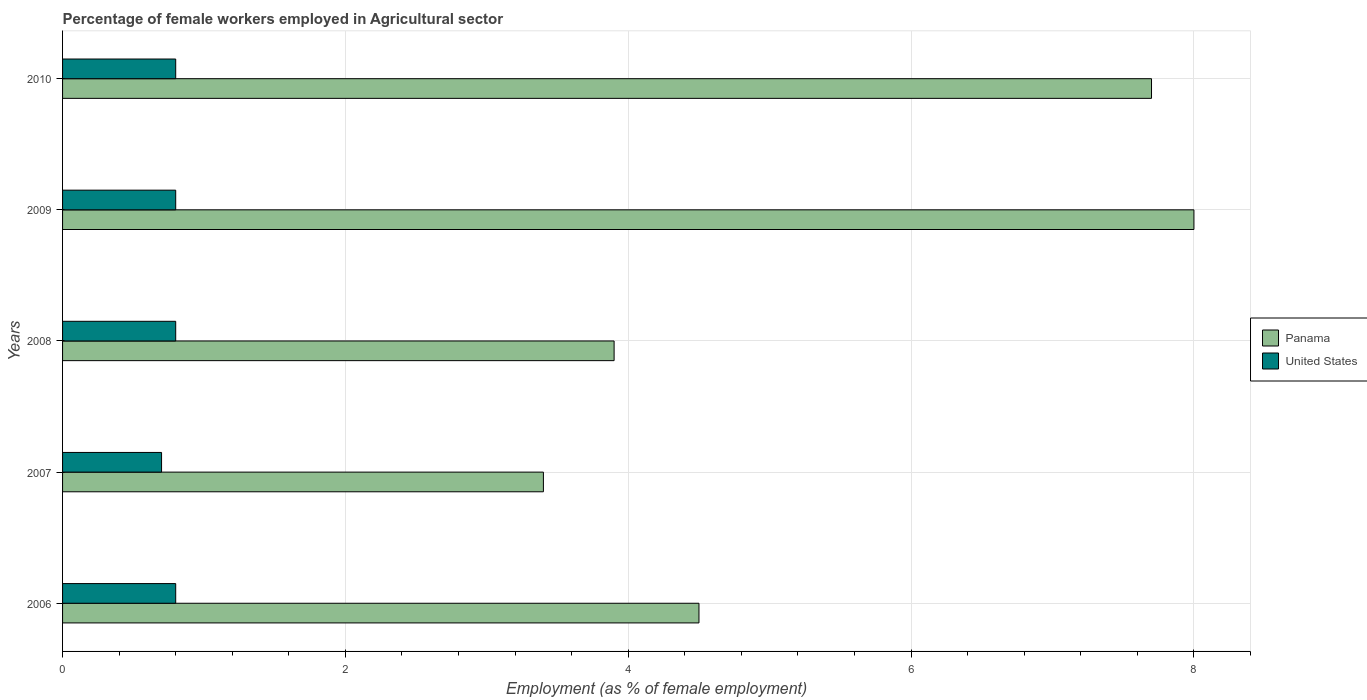How many different coloured bars are there?
Provide a succinct answer. 2. How many groups of bars are there?
Provide a short and direct response. 5. Are the number of bars on each tick of the Y-axis equal?
Make the answer very short. Yes. How many bars are there on the 3rd tick from the bottom?
Offer a terse response. 2. What is the label of the 4th group of bars from the top?
Give a very brief answer. 2007. What is the percentage of females employed in Agricultural sector in Panama in 2007?
Keep it short and to the point. 3.4. Across all years, what is the maximum percentage of females employed in Agricultural sector in United States?
Offer a terse response. 0.8. Across all years, what is the minimum percentage of females employed in Agricultural sector in Panama?
Your answer should be very brief. 3.4. What is the total percentage of females employed in Agricultural sector in United States in the graph?
Give a very brief answer. 3.9. What is the difference between the percentage of females employed in Agricultural sector in Panama in 2006 and that in 2009?
Provide a succinct answer. -3.5. What is the difference between the percentage of females employed in Agricultural sector in Panama in 2006 and the percentage of females employed in Agricultural sector in United States in 2008?
Make the answer very short. 3.7. In the year 2010, what is the difference between the percentage of females employed in Agricultural sector in United States and percentage of females employed in Agricultural sector in Panama?
Provide a short and direct response. -6.9. What is the ratio of the percentage of females employed in Agricultural sector in Panama in 2007 to that in 2009?
Offer a terse response. 0.43. Is the percentage of females employed in Agricultural sector in Panama in 2008 less than that in 2010?
Keep it short and to the point. Yes. Is the difference between the percentage of females employed in Agricultural sector in United States in 2007 and 2008 greater than the difference between the percentage of females employed in Agricultural sector in Panama in 2007 and 2008?
Keep it short and to the point. Yes. What is the difference between the highest and the second highest percentage of females employed in Agricultural sector in Panama?
Ensure brevity in your answer.  0.3. What is the difference between the highest and the lowest percentage of females employed in Agricultural sector in Panama?
Offer a very short reply. 4.6. In how many years, is the percentage of females employed in Agricultural sector in United States greater than the average percentage of females employed in Agricultural sector in United States taken over all years?
Offer a very short reply. 4. Is the sum of the percentage of females employed in Agricultural sector in Panama in 2008 and 2009 greater than the maximum percentage of females employed in Agricultural sector in United States across all years?
Ensure brevity in your answer.  Yes. What does the 2nd bar from the top in 2009 represents?
Offer a very short reply. Panama. What does the 2nd bar from the bottom in 2009 represents?
Offer a terse response. United States. Are all the bars in the graph horizontal?
Your response must be concise. Yes. Are the values on the major ticks of X-axis written in scientific E-notation?
Provide a short and direct response. No. Where does the legend appear in the graph?
Make the answer very short. Center right. How are the legend labels stacked?
Provide a succinct answer. Vertical. What is the title of the graph?
Provide a short and direct response. Percentage of female workers employed in Agricultural sector. Does "Least developed countries" appear as one of the legend labels in the graph?
Give a very brief answer. No. What is the label or title of the X-axis?
Ensure brevity in your answer.  Employment (as % of female employment). What is the label or title of the Y-axis?
Provide a succinct answer. Years. What is the Employment (as % of female employment) in United States in 2006?
Your answer should be compact. 0.8. What is the Employment (as % of female employment) of Panama in 2007?
Offer a very short reply. 3.4. What is the Employment (as % of female employment) of United States in 2007?
Offer a terse response. 0.7. What is the Employment (as % of female employment) in Panama in 2008?
Keep it short and to the point. 3.9. What is the Employment (as % of female employment) of United States in 2008?
Provide a succinct answer. 0.8. What is the Employment (as % of female employment) in United States in 2009?
Give a very brief answer. 0.8. What is the Employment (as % of female employment) in Panama in 2010?
Your answer should be compact. 7.7. What is the Employment (as % of female employment) of United States in 2010?
Provide a succinct answer. 0.8. Across all years, what is the maximum Employment (as % of female employment) in Panama?
Make the answer very short. 8. Across all years, what is the maximum Employment (as % of female employment) of United States?
Provide a short and direct response. 0.8. Across all years, what is the minimum Employment (as % of female employment) in Panama?
Offer a terse response. 3.4. Across all years, what is the minimum Employment (as % of female employment) of United States?
Ensure brevity in your answer.  0.7. What is the difference between the Employment (as % of female employment) of United States in 2006 and that in 2007?
Make the answer very short. 0.1. What is the difference between the Employment (as % of female employment) in Panama in 2006 and that in 2008?
Keep it short and to the point. 0.6. What is the difference between the Employment (as % of female employment) in United States in 2006 and that in 2008?
Provide a short and direct response. 0. What is the difference between the Employment (as % of female employment) of United States in 2006 and that in 2009?
Keep it short and to the point. 0. What is the difference between the Employment (as % of female employment) of United States in 2006 and that in 2010?
Keep it short and to the point. 0. What is the difference between the Employment (as % of female employment) of Panama in 2007 and that in 2008?
Your answer should be very brief. -0.5. What is the difference between the Employment (as % of female employment) of United States in 2007 and that in 2009?
Provide a short and direct response. -0.1. What is the difference between the Employment (as % of female employment) of Panama in 2008 and that in 2009?
Your answer should be compact. -4.1. What is the difference between the Employment (as % of female employment) in United States in 2008 and that in 2009?
Make the answer very short. 0. What is the difference between the Employment (as % of female employment) of Panama in 2008 and that in 2010?
Your response must be concise. -3.8. What is the difference between the Employment (as % of female employment) in Panama in 2006 and the Employment (as % of female employment) in United States in 2007?
Your answer should be compact. 3.8. What is the difference between the Employment (as % of female employment) in Panama in 2007 and the Employment (as % of female employment) in United States in 2010?
Your answer should be compact. 2.6. What is the difference between the Employment (as % of female employment) of Panama in 2009 and the Employment (as % of female employment) of United States in 2010?
Provide a short and direct response. 7.2. What is the average Employment (as % of female employment) of United States per year?
Provide a succinct answer. 0.78. In the year 2006, what is the difference between the Employment (as % of female employment) of Panama and Employment (as % of female employment) of United States?
Offer a terse response. 3.7. In the year 2010, what is the difference between the Employment (as % of female employment) in Panama and Employment (as % of female employment) in United States?
Offer a very short reply. 6.9. What is the ratio of the Employment (as % of female employment) of Panama in 2006 to that in 2007?
Provide a succinct answer. 1.32. What is the ratio of the Employment (as % of female employment) of Panama in 2006 to that in 2008?
Offer a very short reply. 1.15. What is the ratio of the Employment (as % of female employment) in United States in 2006 to that in 2008?
Your answer should be compact. 1. What is the ratio of the Employment (as % of female employment) in Panama in 2006 to that in 2009?
Your answer should be compact. 0.56. What is the ratio of the Employment (as % of female employment) in United States in 2006 to that in 2009?
Your answer should be compact. 1. What is the ratio of the Employment (as % of female employment) in Panama in 2006 to that in 2010?
Offer a terse response. 0.58. What is the ratio of the Employment (as % of female employment) of United States in 2006 to that in 2010?
Provide a short and direct response. 1. What is the ratio of the Employment (as % of female employment) of Panama in 2007 to that in 2008?
Make the answer very short. 0.87. What is the ratio of the Employment (as % of female employment) in United States in 2007 to that in 2008?
Keep it short and to the point. 0.88. What is the ratio of the Employment (as % of female employment) in Panama in 2007 to that in 2009?
Your answer should be compact. 0.42. What is the ratio of the Employment (as % of female employment) of Panama in 2007 to that in 2010?
Give a very brief answer. 0.44. What is the ratio of the Employment (as % of female employment) of Panama in 2008 to that in 2009?
Your response must be concise. 0.49. What is the ratio of the Employment (as % of female employment) in United States in 2008 to that in 2009?
Provide a succinct answer. 1. What is the ratio of the Employment (as % of female employment) in Panama in 2008 to that in 2010?
Make the answer very short. 0.51. What is the ratio of the Employment (as % of female employment) of Panama in 2009 to that in 2010?
Keep it short and to the point. 1.04. What is the ratio of the Employment (as % of female employment) in United States in 2009 to that in 2010?
Your answer should be very brief. 1. What is the difference between the highest and the second highest Employment (as % of female employment) in Panama?
Make the answer very short. 0.3. What is the difference between the highest and the second highest Employment (as % of female employment) of United States?
Give a very brief answer. 0. 